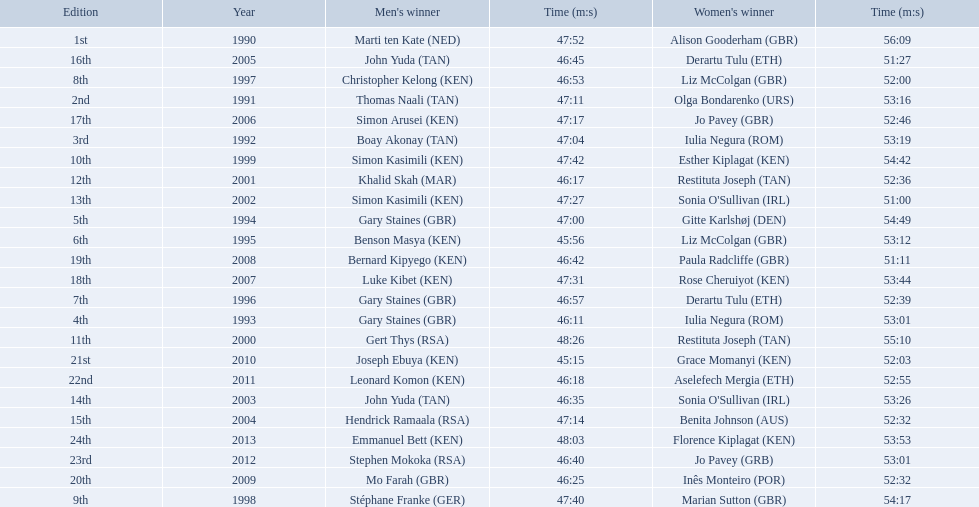Which of the runner in the great south run were women? Alison Gooderham (GBR), Olga Bondarenko (URS), Iulia Negura (ROM), Iulia Negura (ROM), Gitte Karlshøj (DEN), Liz McColgan (GBR), Derartu Tulu (ETH), Liz McColgan (GBR), Marian Sutton (GBR), Esther Kiplagat (KEN), Restituta Joseph (TAN), Restituta Joseph (TAN), Sonia O'Sullivan (IRL), Sonia O'Sullivan (IRL), Benita Johnson (AUS), Derartu Tulu (ETH), Jo Pavey (GBR), Rose Cheruiyot (KEN), Paula Radcliffe (GBR), Inês Monteiro (POR), Grace Momanyi (KEN), Aselefech Mergia (ETH), Jo Pavey (GRB), Florence Kiplagat (KEN). Of those women, which ones had a time of at least 53 minutes? Alison Gooderham (GBR), Olga Bondarenko (URS), Iulia Negura (ROM), Iulia Negura (ROM), Gitte Karlshøj (DEN), Liz McColgan (GBR), Marian Sutton (GBR), Esther Kiplagat (KEN), Restituta Joseph (TAN), Sonia O'Sullivan (IRL), Rose Cheruiyot (KEN), Jo Pavey (GRB), Florence Kiplagat (KEN). Between those women, which ones did not go over 53 minutes? Olga Bondarenko (URS), Iulia Negura (ROM), Iulia Negura (ROM), Liz McColgan (GBR), Sonia O'Sullivan (IRL), Rose Cheruiyot (KEN), Jo Pavey (GRB), Florence Kiplagat (KEN). Of those 8, what were the three slowest times? Sonia O'Sullivan (IRL), Rose Cheruiyot (KEN), Florence Kiplagat (KEN). Between only those 3 women, which runner had the fastest time? Sonia O'Sullivan (IRL). What was this women's time? 53:26. 